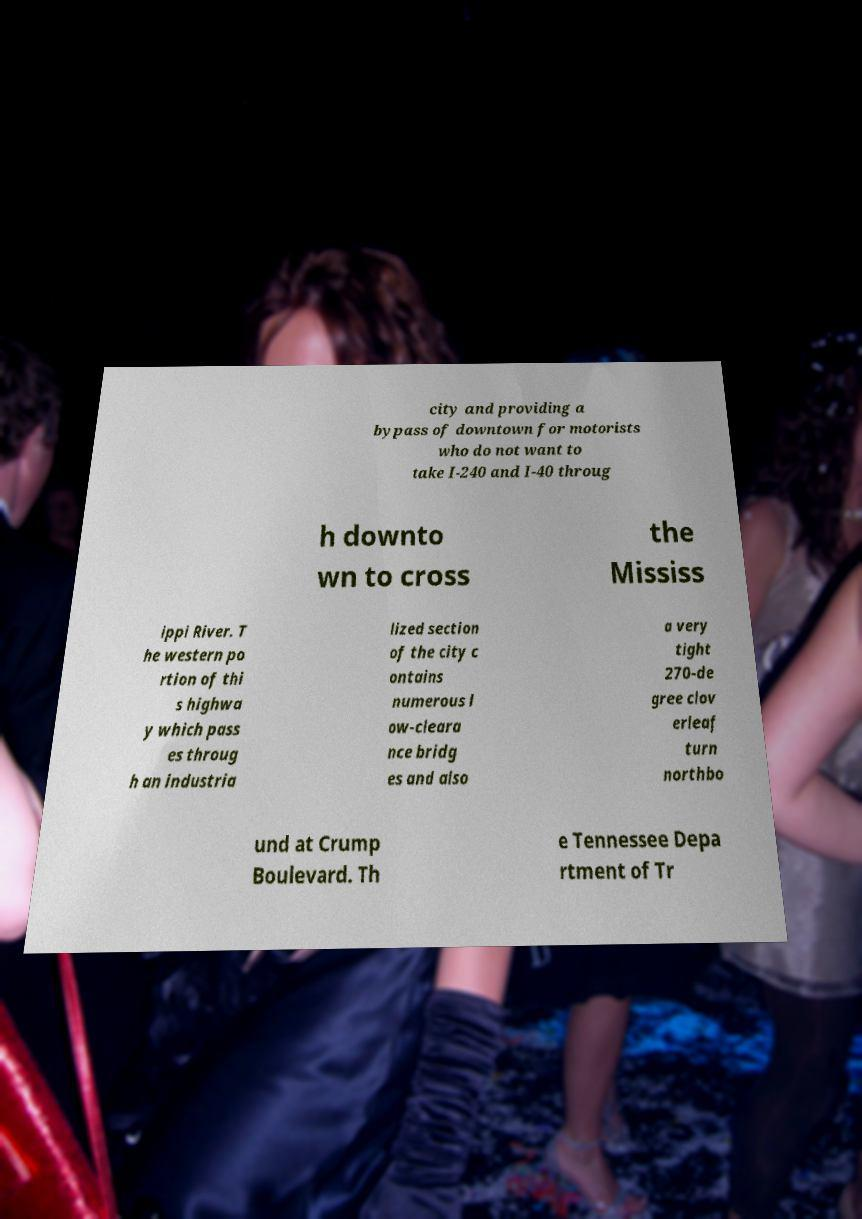Can you read and provide the text displayed in the image?This photo seems to have some interesting text. Can you extract and type it out for me? city and providing a bypass of downtown for motorists who do not want to take I-240 and I-40 throug h downto wn to cross the Mississ ippi River. T he western po rtion of thi s highwa y which pass es throug h an industria lized section of the city c ontains numerous l ow-cleara nce bridg es and also a very tight 270-de gree clov erleaf turn northbo und at Crump Boulevard. Th e Tennessee Depa rtment of Tr 